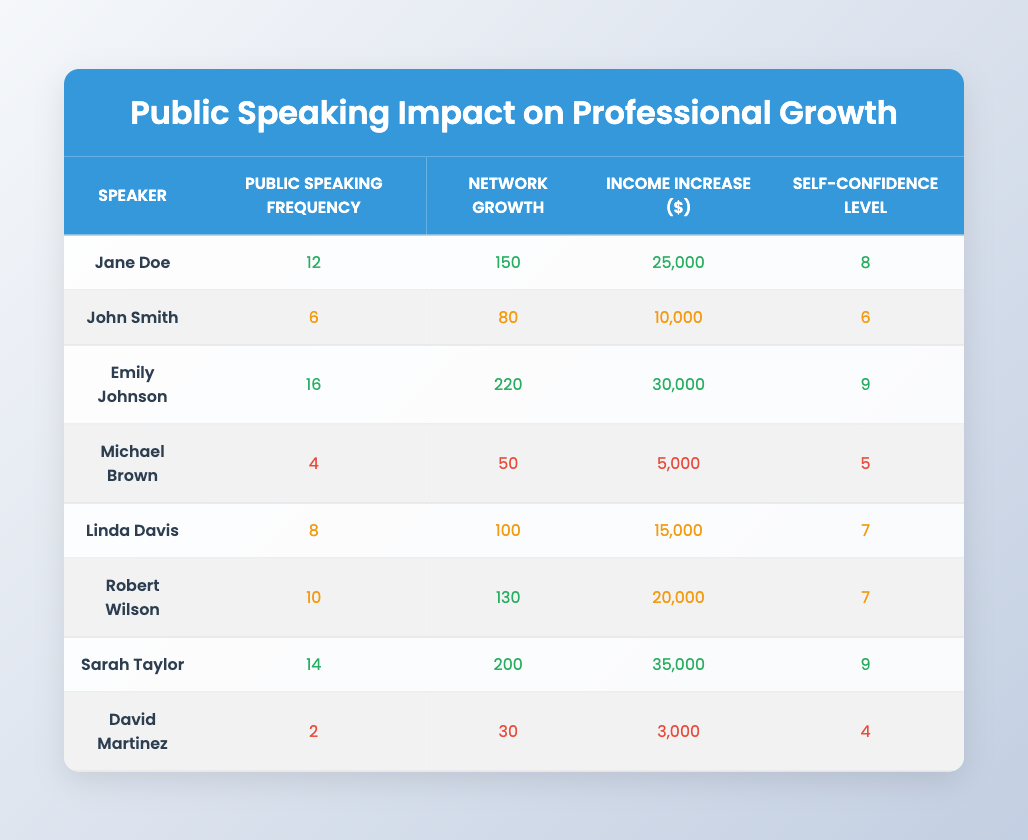How many speakers have a public speaking frequency of 10 or more? From the table, I will filter the public speaking frequency column and count the number of entries that are 10 or above. The relevant speakers are: Jane Doe, Emily Johnson, Robert Wilson, Sarah Taylor. Therefore, there are four speakers.
Answer: 4 What is the income increase for Sarah Taylor? Looking at the table, I find Sarah Taylor's row, and the income increase is listed as 35,000 dollars.
Answer: 35,000 Who has the highest self-confidence level? I will check the self-confidence level column to identify the highest value. The highest level is 9, which corresponds to Emily Johnson and Sarah Taylor. Therefore, there are two speakers with the highest level.
Answer: Emily Johnson and Sarah Taylor What is the average network growth for speakers with a public speaking frequency of less than 6? I'll identify the applicable speakers: David Martinez (30) and Michael Brown (50). Summing these values gives 30 + 50 = 80. There are two speakers, so I find the average by dividing the total by the number of speakers: 80 / 2 = 40.
Answer: 40 Is it true that speakers with higher public speaking frequency generally have a higher income increase? I will compare the public speaking frequency and income increase across all speakers. Observing the data indicates that speakers with higher frequencies (like Emily Johnson and Sarah Taylor) tend to have higher income increases, while speakers with lower frequencies (like David Martinez and Michael Brown) have lower increases. Thus, the statement is generally true.
Answer: Yes What is the correlation between public speaking frequency and self-confidence level? Analyzing the values in both columns, I see a positive trend: as the public speaking frequency increases, the self-confidence level also tends to increase. This suggests a reasonable correlation.
Answer: Positive correlation How does Linda Davis’ network growth compare with John Smith's? I will look at the network growth values for both speakers. Linda Davis has a network growth of 100, while John Smith has a network growth of 80. Therefore, Linda Davis’ network growth is greater.
Answer: Linda Davis has higher network growth What is the total income increase for all speakers? Summing the income increases: 25,000 + 10,000 + 30,000 + 5,000 + 15,000 + 20,000 + 35,000 + 3,000 equals 143,000.
Answer: 143,000 Which speaker has the lowest public speaking frequency? I will verify the public speaking frequency column and find David Martinez with a frequency of 2, which is the lowest.
Answer: David Martinez 